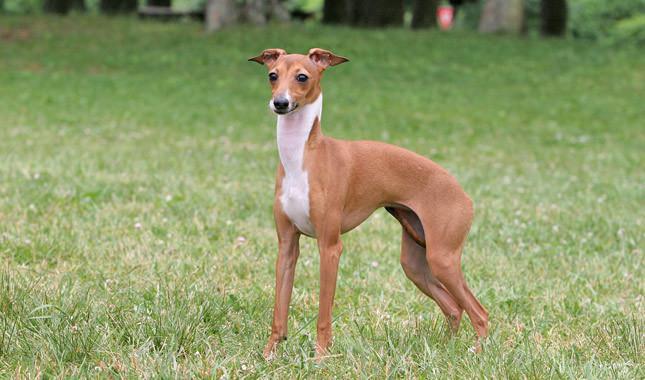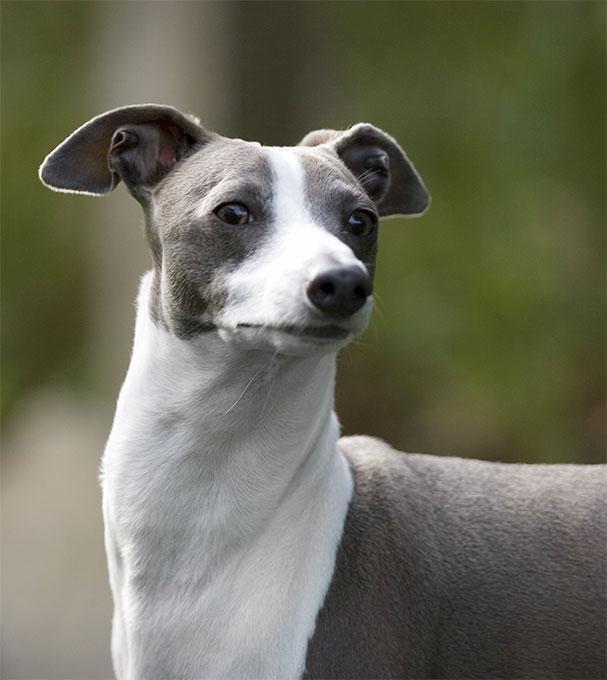The first image is the image on the left, the second image is the image on the right. For the images displayed, is the sentence "The dog's legs are not visible in one of the images." factually correct? Answer yes or no. Yes. 